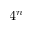<formula> <loc_0><loc_0><loc_500><loc_500>4 ^ { n }</formula> 